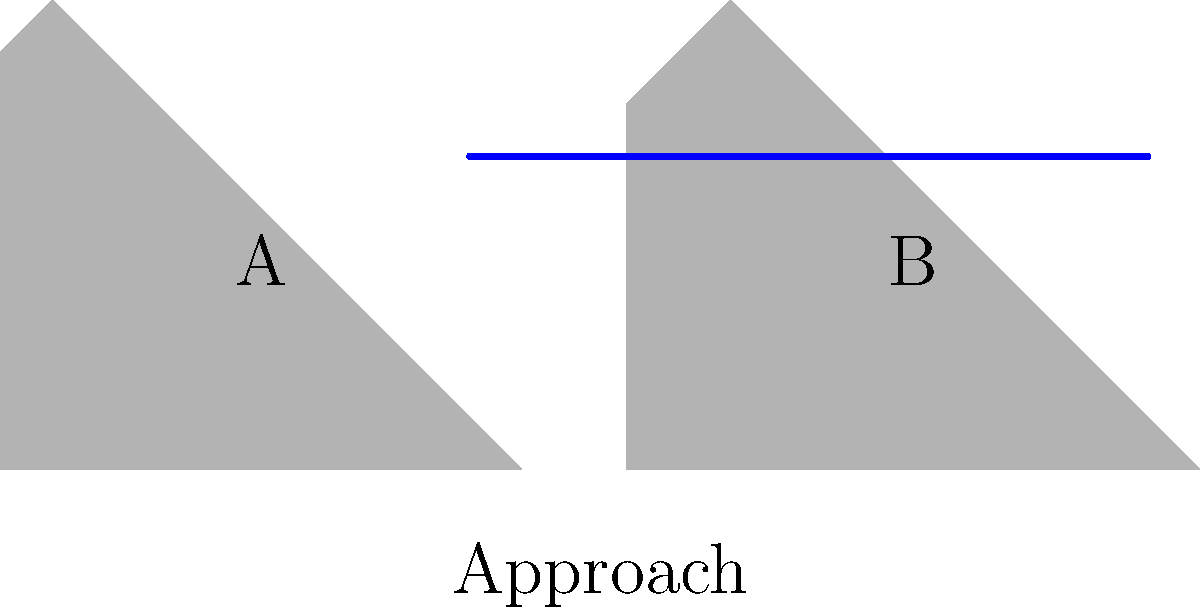Based on your experience as a former professional track and field athlete, which silhouette (A or B) demonstrates the more efficient Fosbury Flop technique for clearing the high jump bar? To analyze the efficiency of the Fosbury Flop technique in high jump, we need to consider several key aspects:

1. Approach: Both silhouettes show a curved approach, which is characteristic of the Fosbury Flop technique.

2. Take-off position: 
   - Silhouette A shows a more upright position at take-off.
   - Silhouette B demonstrates a lower center of gravity and a more pronounced lean away from the bar.

3. Body arch:
   - Silhouette A has a less pronounced arch over the bar.
   - Silhouette B shows a more significant arch, with the hips clearly higher than the head and feet.

4. Clearance height:
   - Silhouette A's highest point is noticeably lower than the bar.
   - Silhouette B's hip position is higher relative to the bar.

5. Efficiency of movement:
   - Silhouette A appears to be jumping more vertically, which is less efficient.
   - Silhouette B shows a more horizontal movement over the bar, utilizing the momentum from the approach.

The Fosbury Flop technique is most effective when the jumper can convert horizontal momentum into vertical lift while minimizing the height needed to clear the bar. Silhouette B demonstrates this principle more effectively by showing:
   a) A lower take-off position
   b) A more pronounced body arch
   c) A higher hip position relative to the bar
   d) A more horizontal trajectory over the bar

These factors allow the jumper in Silhouette B to clear a higher bar with potentially less vertical jump height, making it the more efficient technique.
Answer: Silhouette B 